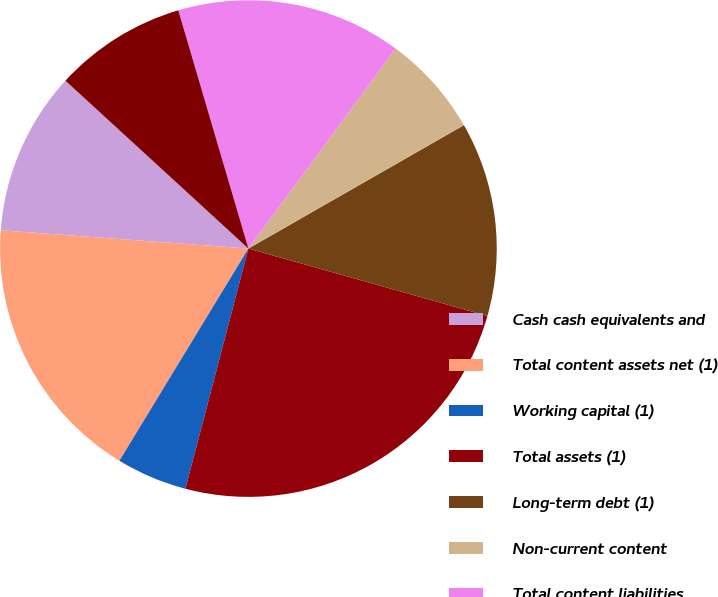<chart> <loc_0><loc_0><loc_500><loc_500><pie_chart><fcel>Cash cash equivalents and<fcel>Total content assets net (1)<fcel>Working capital (1)<fcel>Total assets (1)<fcel>Long-term debt (1)<fcel>Non-current content<fcel>Total content liabilities<fcel>Total stockholders' equity<nl><fcel>10.64%<fcel>17.48%<fcel>4.61%<fcel>24.71%<fcel>12.65%<fcel>6.62%<fcel>14.66%<fcel>8.63%<nl></chart> 